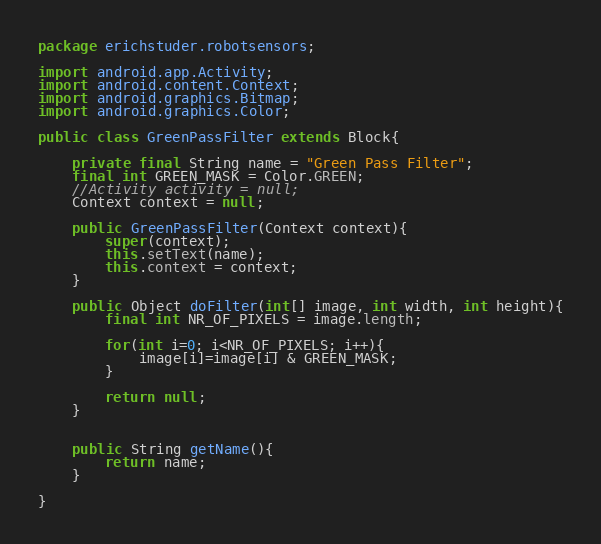<code> <loc_0><loc_0><loc_500><loc_500><_Java_>package erichstuder.robotsensors;

import android.app.Activity;
import android.content.Context;
import android.graphics.Bitmap;
import android.graphics.Color;

public class GreenPassFilter extends Block{

	private final String name = "Green Pass Filter";
	final int GREEN_MASK = Color.GREEN;
	//Activity activity = null;
	Context context = null;
	
	public GreenPassFilter(Context context){
		super(context);
		this.setText(name);
		this.context = context;
	}
	
	public Object doFilter(int[] image, int width, int height){
		final int NR_OF_PIXELS = image.length;
		
		for(int i=0; i<NR_OF_PIXELS; i++){
			image[i]=image[i] & GREEN_MASK;
		}
		
		return null;
	}
	
	
	public String getName(){
		return name;
	}
	
}</code> 